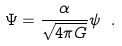Convert formula to latex. <formula><loc_0><loc_0><loc_500><loc_500>\Psi = \frac { \alpha } { \sqrt { 4 \pi G } } \psi \ .</formula> 